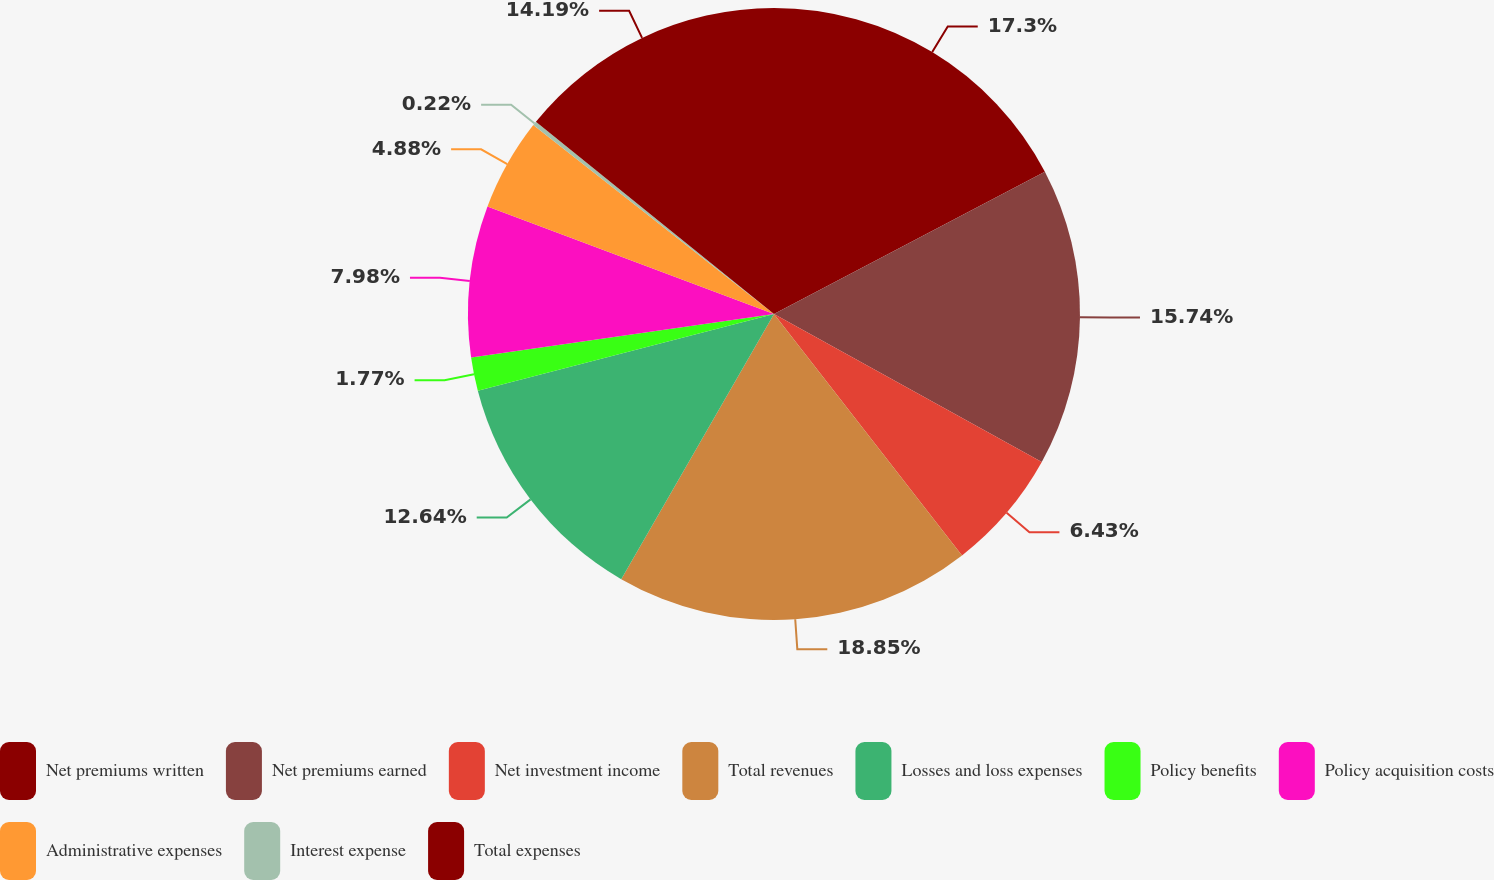<chart> <loc_0><loc_0><loc_500><loc_500><pie_chart><fcel>Net premiums written<fcel>Net premiums earned<fcel>Net investment income<fcel>Total revenues<fcel>Losses and loss expenses<fcel>Policy benefits<fcel>Policy acquisition costs<fcel>Administrative expenses<fcel>Interest expense<fcel>Total expenses<nl><fcel>17.3%<fcel>15.74%<fcel>6.43%<fcel>18.85%<fcel>12.64%<fcel>1.77%<fcel>7.98%<fcel>4.88%<fcel>0.22%<fcel>14.19%<nl></chart> 